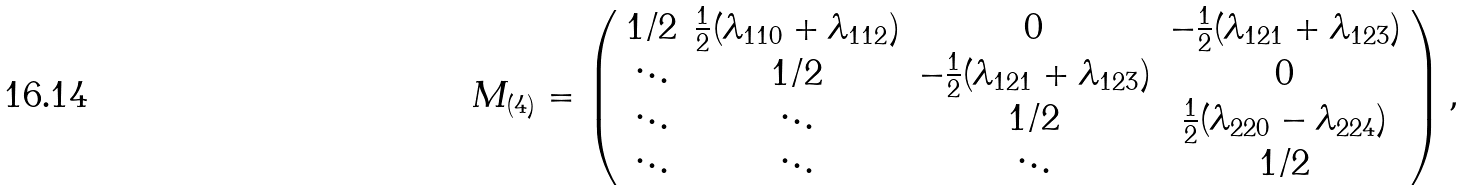<formula> <loc_0><loc_0><loc_500><loc_500>M _ { ( 4 ) } = \left ( \begin{array} { c c c c } 1 / 2 & \frac { 1 } { 2 } ( \lambda _ { 1 1 0 } + \lambda _ { 1 1 2 } ) & 0 & - \frac { 1 } { 2 } ( \lambda _ { 1 2 1 } + \lambda _ { 1 2 3 } ) \\ \ddots & 1 / 2 & - \frac { 1 } { 2 } ( \lambda _ { 1 2 1 } + \lambda _ { 1 2 3 } ) & 0 \\ \ddots & \ddots & 1 / 2 & \frac { 1 } { 2 } ( \lambda _ { 2 2 0 } - \lambda _ { 2 2 4 } ) \\ \ddots & \ddots & \ddots & 1 / 2 \end{array} \right ) ,</formula> 